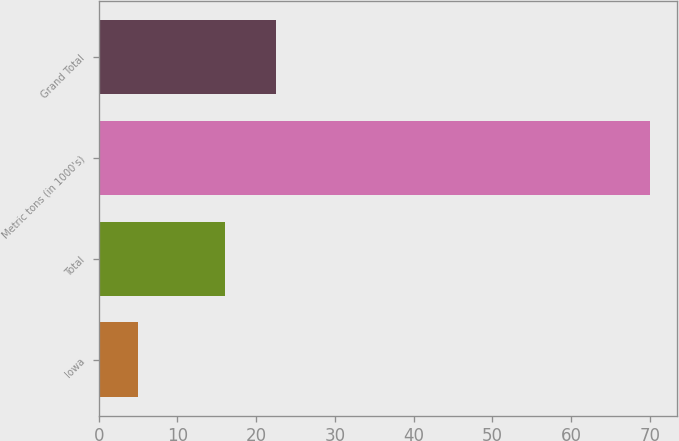Convert chart to OTSL. <chart><loc_0><loc_0><loc_500><loc_500><bar_chart><fcel>Iowa<fcel>Total<fcel>Metric tons (in 1000's)<fcel>Grand Total<nl><fcel>5<fcel>16<fcel>70<fcel>22.5<nl></chart> 